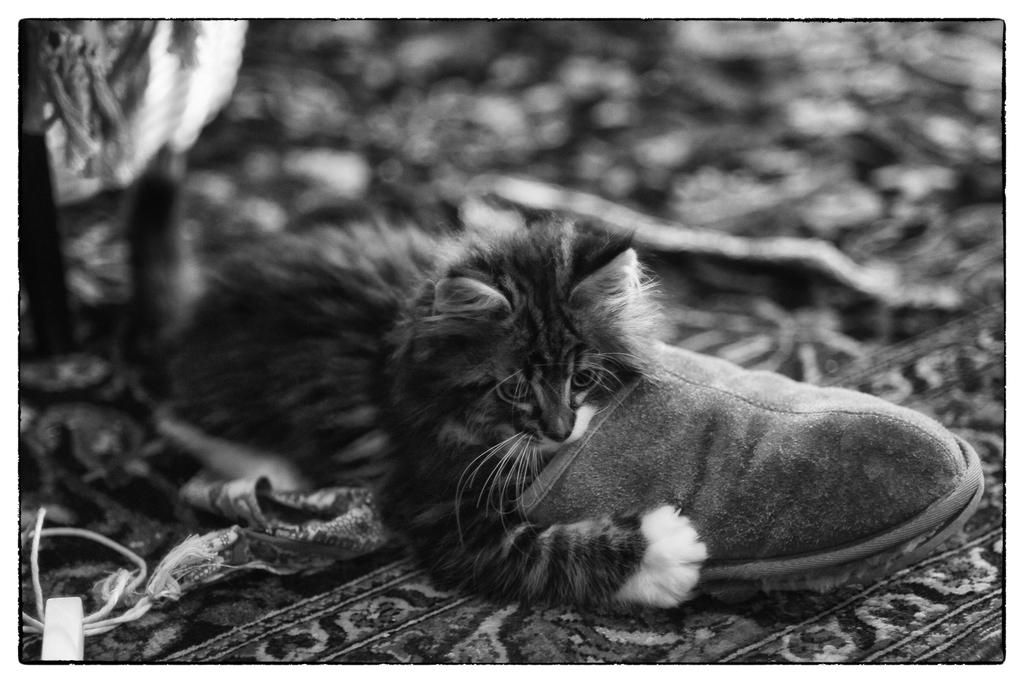What type of animal is present in the image? There is a cat in the picture. What other object can be seen in the image? There is a footwear in the picture. How would you describe the background of the image? The background of the image is blurred. What color scheme is used in the image? The picture is black and white in color. How many straws are being used by the cat in the image? There are no straws present in the image, as it features a cat and footwear in a black and white, blurred background. 